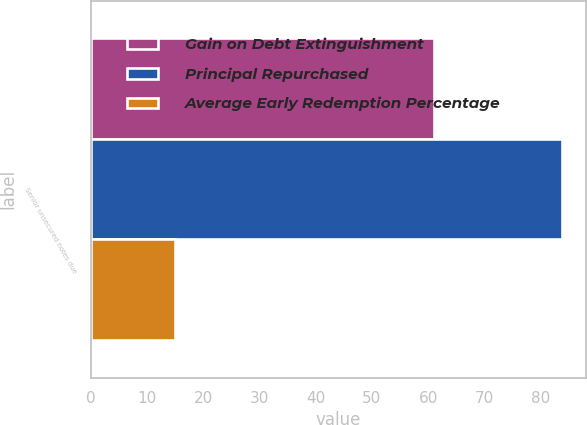Convert chart to OTSL. <chart><loc_0><loc_0><loc_500><loc_500><stacked_bar_chart><ecel><fcel>Senior unsecured notes due<nl><fcel>Gain on Debt Extinguishment<fcel>61<nl><fcel>Principal Repurchased<fcel>83.85<nl><fcel>Average Early Redemption Percentage<fcel>15<nl></chart> 